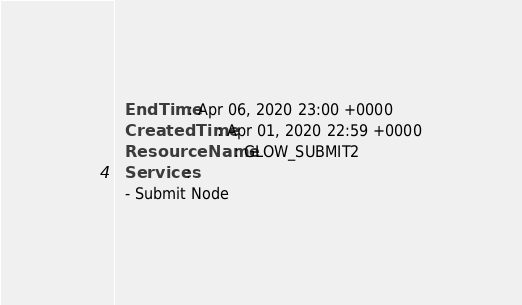Convert code to text. <code><loc_0><loc_0><loc_500><loc_500><_YAML_>  EndTime: Apr 06, 2020 23:00 +0000
  CreatedTime: Apr 01, 2020 22:59 +0000
  ResourceName: GLOW_SUBMIT2
  Services:
  - Submit Node</code> 